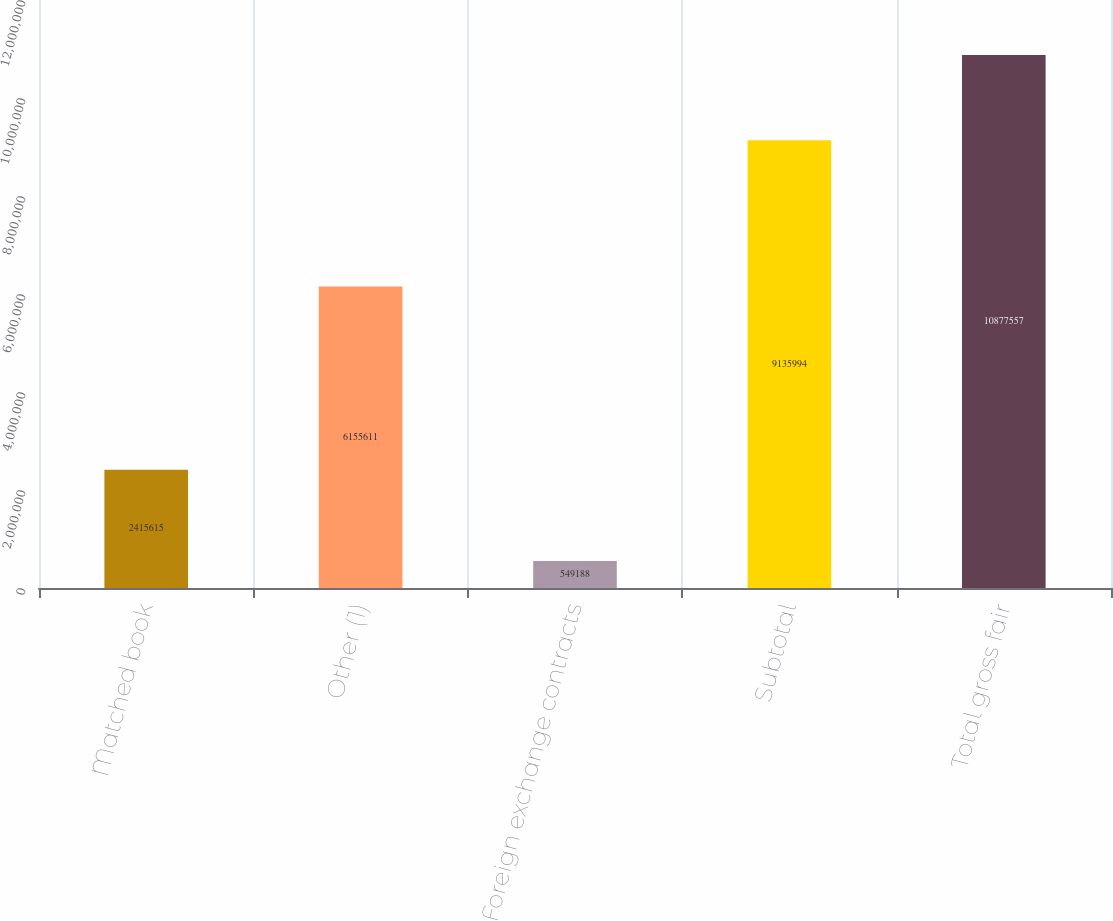Convert chart. <chart><loc_0><loc_0><loc_500><loc_500><bar_chart><fcel>Matched book<fcel>Other (1)<fcel>Foreign exchange contracts<fcel>Subtotal<fcel>Total gross fair<nl><fcel>2.41562e+06<fcel>6.15561e+06<fcel>549188<fcel>9.13599e+06<fcel>1.08776e+07<nl></chart> 